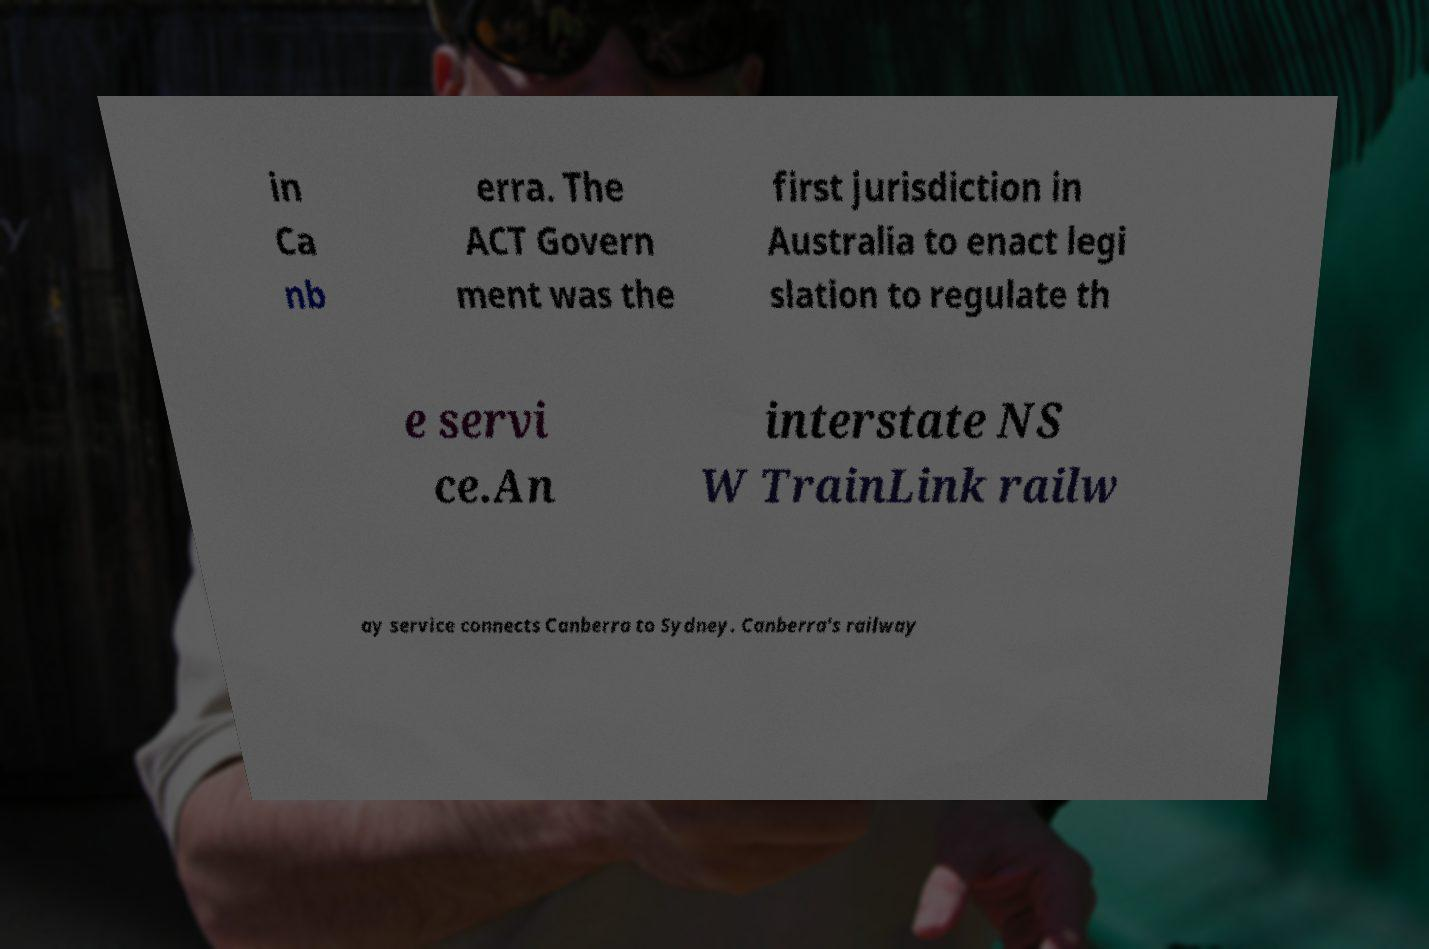Please identify and transcribe the text found in this image. in Ca nb erra. The ACT Govern ment was the first jurisdiction in Australia to enact legi slation to regulate th e servi ce.An interstate NS W TrainLink railw ay service connects Canberra to Sydney. Canberra's railway 